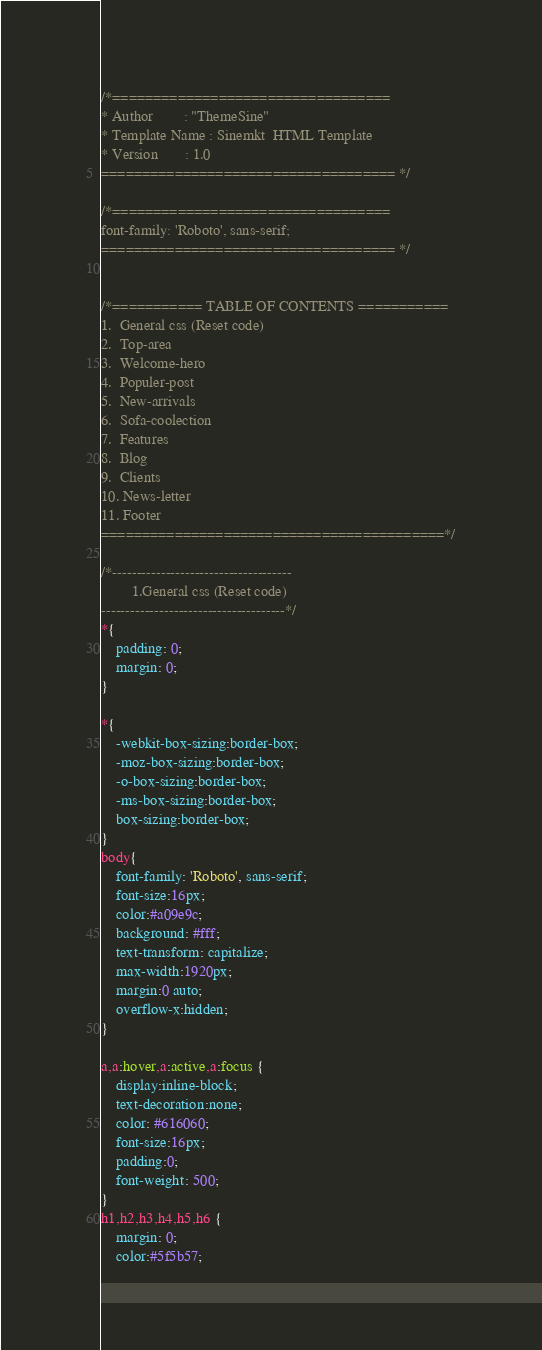<code> <loc_0><loc_0><loc_500><loc_500><_CSS_>/*==================================
* Author        : "ThemeSine"
* Template Name : Sinemkt  HTML Template
* Version       : 1.0
==================================== */

/*==================================
font-family: 'Roboto', sans-serif;
==================================== */


/*=========== TABLE OF CONTENTS ===========
1.  General css (Reset code)
2.  Top-area
3.  Welcome-hero
4.  Populer-post
5.  New-arrivals  
6.  Sofa-coolection
7.  Features
8.  Blog
9.  Clients
10. News-letter
11. Footer
==========================================*/

/*-------------------------------------
		1.General css (Reset code)
--------------------------------------*/
*{
    padding: 0;
    margin: 0;
}

*{
	-webkit-box-sizing:border-box;
	-moz-box-sizing:border-box;
	-o-box-sizing:border-box;
	-ms-box-sizing:border-box;
	box-sizing:border-box;
}
body{
	font-family: 'Roboto', sans-serif;
	font-size:16px;
	color:#a09e9c;
	background: #fff;
    text-transform: capitalize;
    max-width:1920px;
    margin:0 auto;
	overflow-x:hidden;
}

a,a:hover,a:active,a:focus {
	display:inline-block;
	text-decoration:none;
	color: #616060;
	font-size:16px;
	padding:0;
    font-weight: 500;
}
h1,h2,h3,h4,h5,h6 { 
	margin: 0;
	color:#5f5b57;</code> 